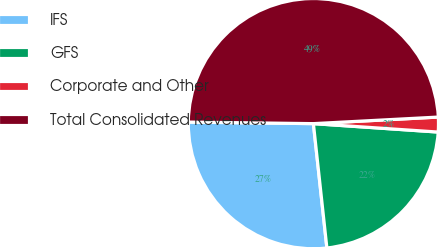Convert chart to OTSL. <chart><loc_0><loc_0><loc_500><loc_500><pie_chart><fcel>IFS<fcel>GFS<fcel>Corporate and Other<fcel>Total Consolidated Revenues<nl><fcel>26.92%<fcel>22.21%<fcel>1.91%<fcel>48.97%<nl></chart> 